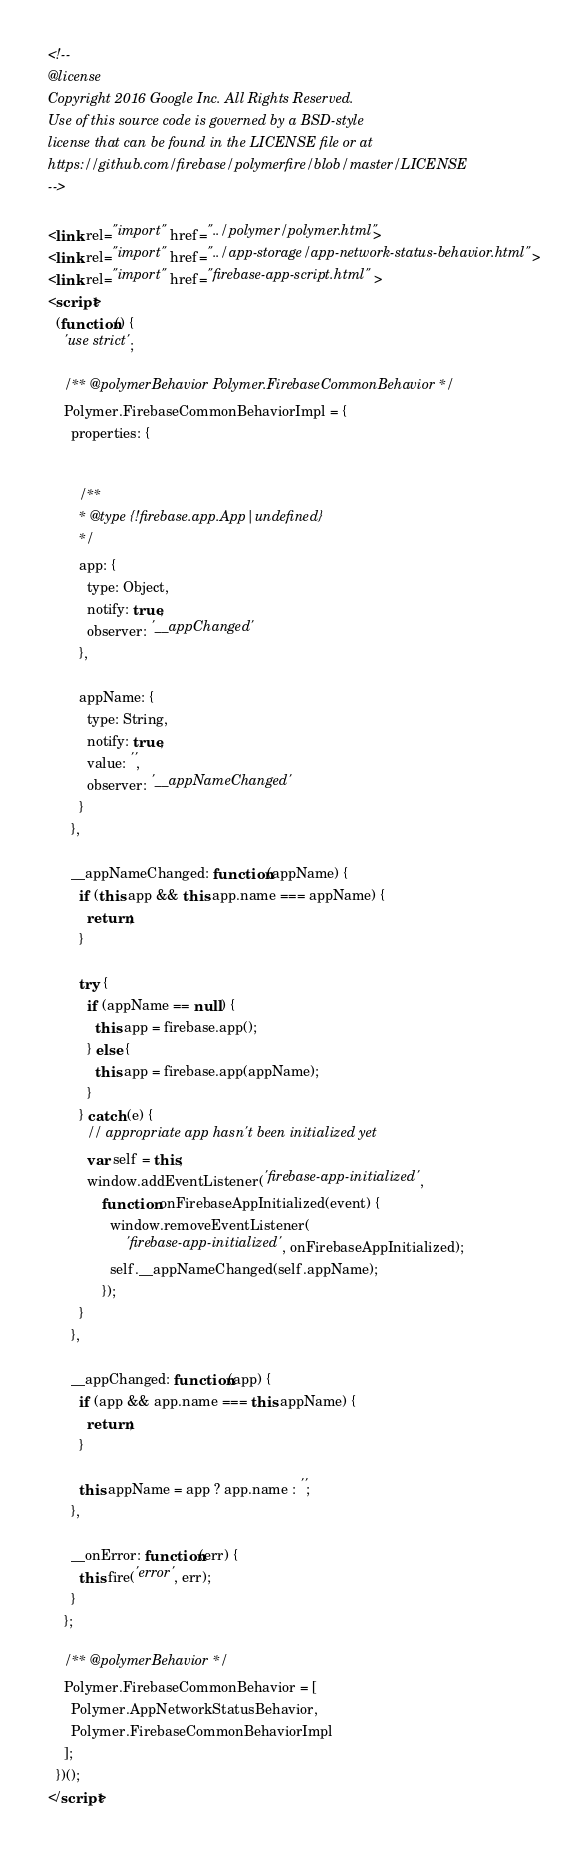Convert code to text. <code><loc_0><loc_0><loc_500><loc_500><_HTML_><!--
@license
Copyright 2016 Google Inc. All Rights Reserved.
Use of this source code is governed by a BSD-style
license that can be found in the LICENSE file or at
https://github.com/firebase/polymerfire/blob/master/LICENSE
-->

<link rel="import" href="../polymer/polymer.html">
<link rel="import" href="../app-storage/app-network-status-behavior.html">
<link rel="import" href="firebase-app-script.html">
<script>
  (function() {
    'use strict';

    /** @polymerBehavior Polymer.FirebaseCommonBehavior */
    Polymer.FirebaseCommonBehaviorImpl = {
      properties: {


        /**
        * @type {!firebase.app.App|undefined}
        */
        app: {
          type: Object,
          notify: true,
          observer: '__appChanged'
        },

        appName: {
          type: String,
          notify: true,
          value: '',
          observer: '__appNameChanged'
        }
      },

      __appNameChanged: function(appName) {
        if (this.app && this.app.name === appName) {
          return;
        }

        try {
          if (appName == null) {
            this.app = firebase.app();
          } else {
            this.app = firebase.app(appName);
          }
        } catch (e) {
          // appropriate app hasn't been initialized yet
          var self = this;
          window.addEventListener('firebase-app-initialized',
              function onFirebaseAppInitialized(event) {
                window.removeEventListener(
                    'firebase-app-initialized', onFirebaseAppInitialized);
                self.__appNameChanged(self.appName);
              });
        }
      },

      __appChanged: function(app) {
        if (app && app.name === this.appName) {
          return;
        }

        this.appName = app ? app.name : '';
      },

      __onError: function(err) {
        this.fire('error', err);
      }
    };

    /** @polymerBehavior */
    Polymer.FirebaseCommonBehavior = [
      Polymer.AppNetworkStatusBehavior,
      Polymer.FirebaseCommonBehaviorImpl
    ];
  })();
</script>
</code> 